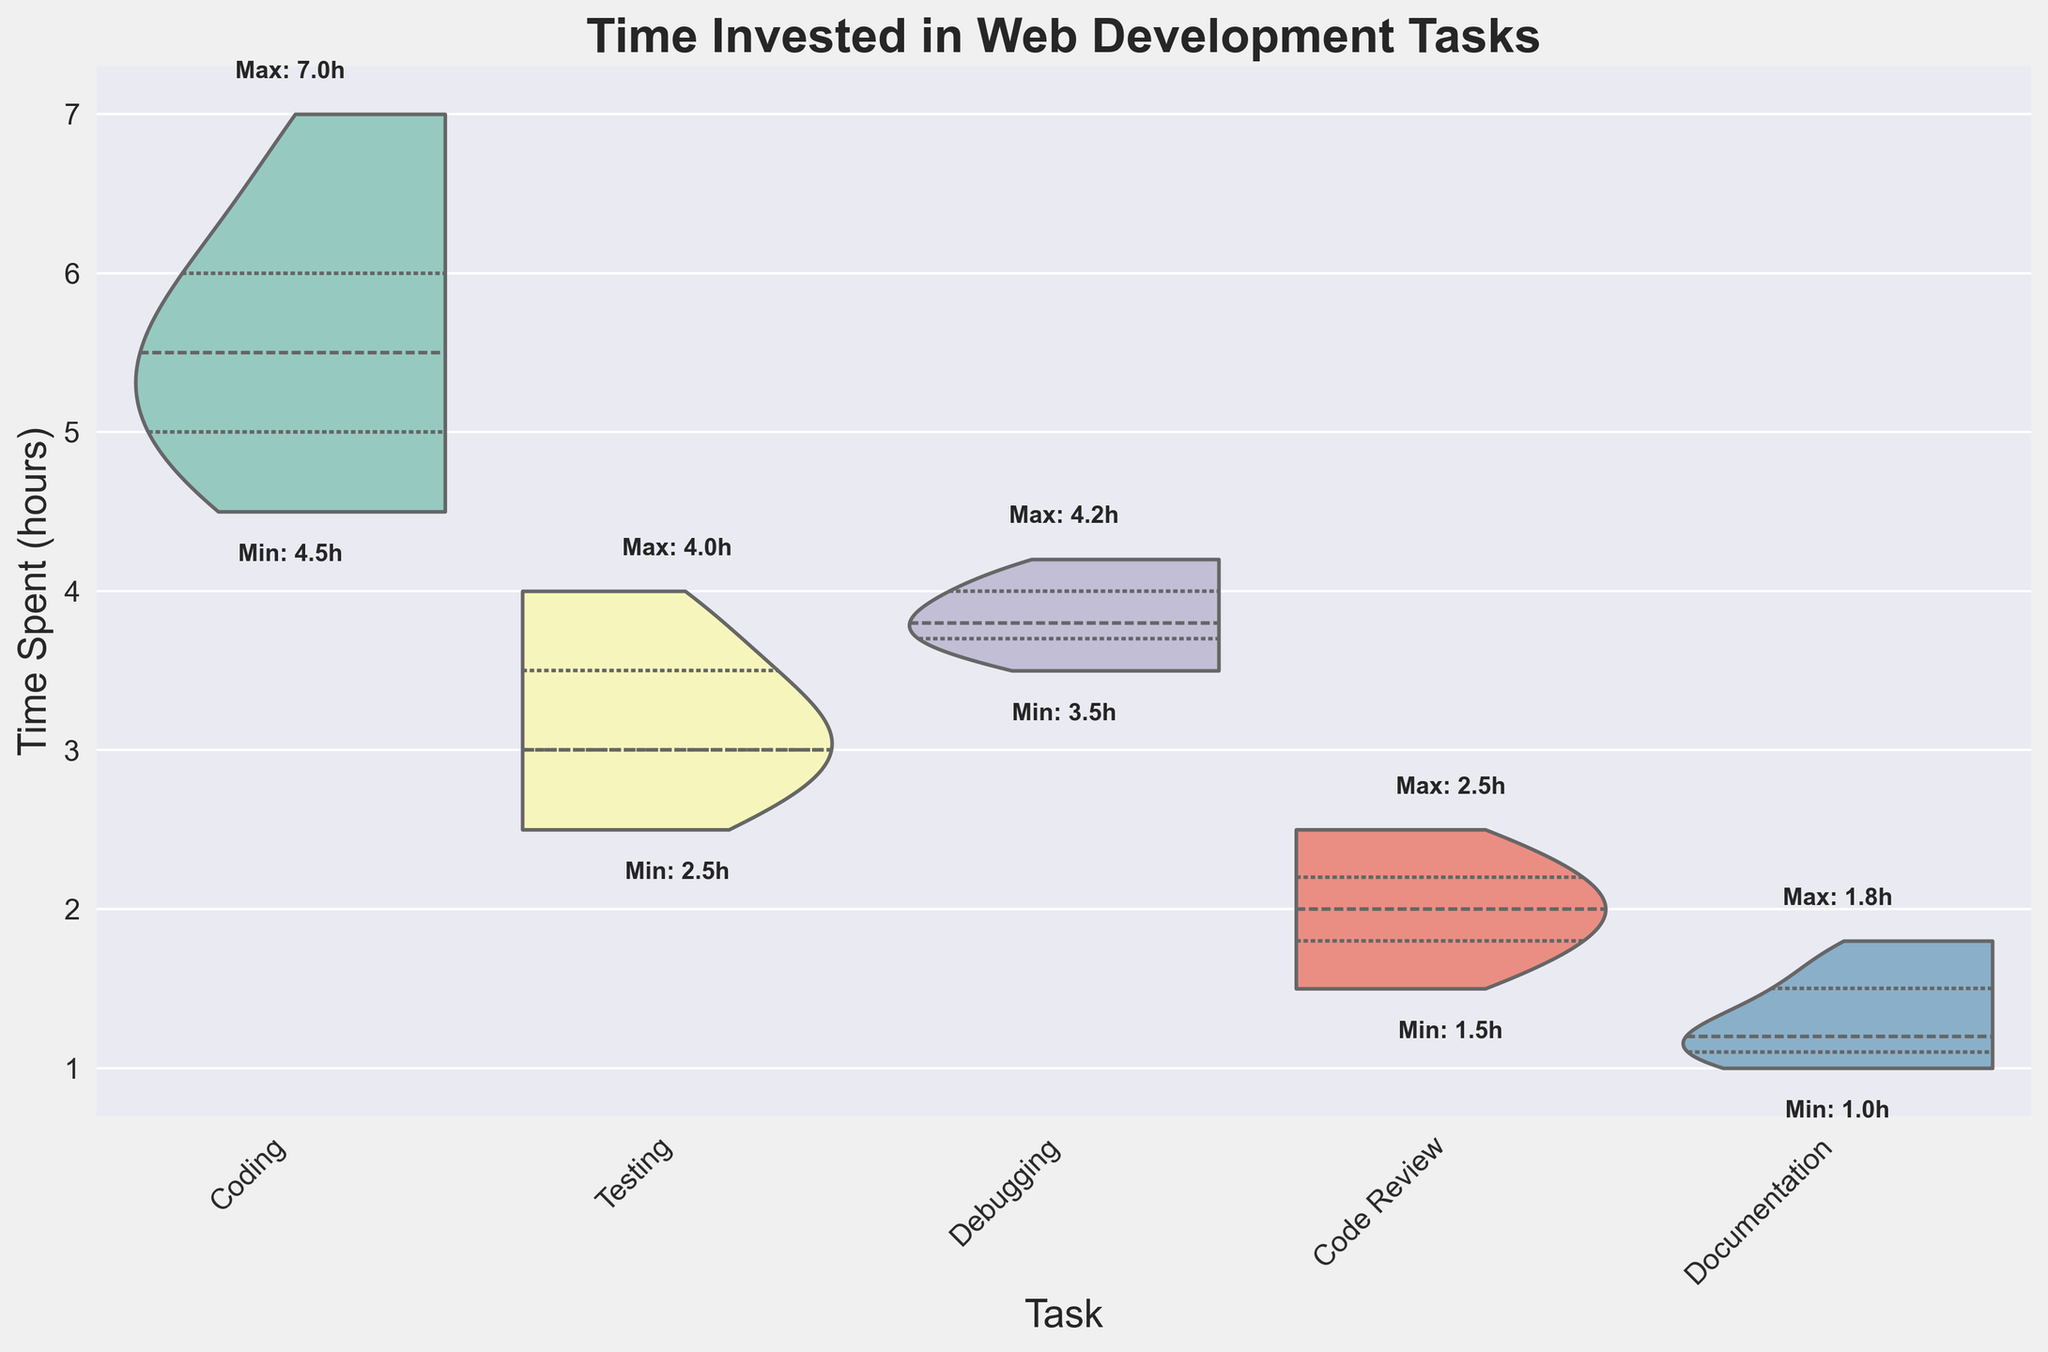What is the title of the chart? The title of the chart is displayed at the top of the figure.
Answer: "Time Invested in Web Development Tasks" How many distinct tasks are displayed in the chart? By counting the unique categories along the x-axis, we find the number of distinct tasks.
Answer: 5 Which task has the highest maximum time spent, and what is that time? We look for the highest maximum time label just above the top of each violin plot. The coding task has the highest label.
Answer: Coding, 7.0 hours What is the minimum time spent on Code Review, and how does it compare to the minimum time spent on Debugging? Check the minimum time labels just below each violin plot for Code Review and Debugging. Code Review has 1.5 hours and Debugging has 3.5 hours.
Answer: Code Review, 1.5 hours; Debugging, 3.5 hours What is the median time spent on Testing? The median is marked within the violin plot, which shows a thicker section around the middle. For Testing, it is approximately 3 hours.
Answer: 3 hours Which task has the lowest median time spent, and how does it compare to the median time spent on Coding? Look at the thicker section in the middle of each violin plot to find the medians. Documentation has the lowest median. Documentation median is around 1.5 hours, Codings median is around 5.5 hours.
Answer: Documentation, 1.5 hours; Coding, 5.5 hours How does the range of time spent on Bug Fixing compare with that of Testing? The range can be calculated by subtracting the minimum from the maximum for each category. For Bug Fixing, the range is 4.2 - 3.5, and for Testing, it is 4.0 - 2.5. `Debugging range = 0.7 hours`, `Testing range = 1.5 hours`
Answer: Debugging range = 0.7 hours; Testing range = 1.5 hours Which task shows the highest variability in time spent? Variability can be inferred from the width and spread of the violin plot. Coding has the widest spread indicating the highest variability.
Answer: Coding What can you infer about the consistency of time allocation to Documentation tasks? The narrow spread of the violin plot and the close minimum and maximum labels suggest that the time spent on Documentation tasks has low variability and is relatively consistent.
Answer: Consistent What is the general trend of time spent across non-coding tasks compared to coding? By visually comparing the distribution and ranges of time spent on each task, one can see that non-coding tasks generally have lower maximums and smaller ranges than coding.
Answer: Non-coding tasks generally have lower time spent and smaller ranges than coding tasks 